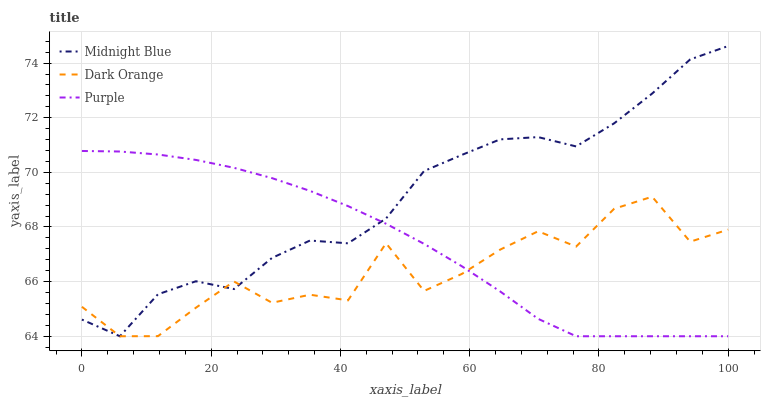Does Dark Orange have the minimum area under the curve?
Answer yes or no. Yes. Does Midnight Blue have the maximum area under the curve?
Answer yes or no. Yes. Does Midnight Blue have the minimum area under the curve?
Answer yes or no. No. Does Dark Orange have the maximum area under the curve?
Answer yes or no. No. Is Purple the smoothest?
Answer yes or no. Yes. Is Dark Orange the roughest?
Answer yes or no. Yes. Is Midnight Blue the smoothest?
Answer yes or no. No. Is Midnight Blue the roughest?
Answer yes or no. No. Does Purple have the lowest value?
Answer yes or no. Yes. Does Midnight Blue have the highest value?
Answer yes or no. Yes. Does Dark Orange have the highest value?
Answer yes or no. No. Does Midnight Blue intersect Purple?
Answer yes or no. Yes. Is Midnight Blue less than Purple?
Answer yes or no. No. Is Midnight Blue greater than Purple?
Answer yes or no. No. 